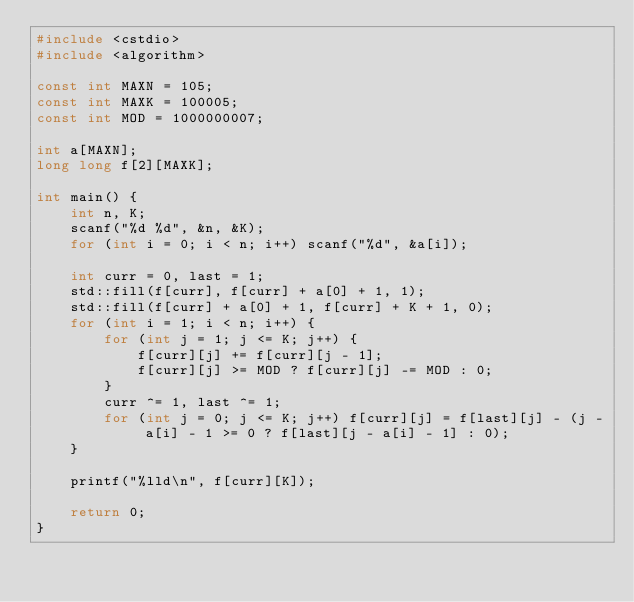<code> <loc_0><loc_0><loc_500><loc_500><_C++_>#include <cstdio>
#include <algorithm>

const int MAXN = 105;
const int MAXK = 100005;
const int MOD = 1000000007;

int a[MAXN];
long long f[2][MAXK];

int main() {
    int n, K;
    scanf("%d %d", &n, &K);
    for (int i = 0; i < n; i++) scanf("%d", &a[i]);

    int curr = 0, last = 1;
    std::fill(f[curr], f[curr] + a[0] + 1, 1);
    std::fill(f[curr] + a[0] + 1, f[curr] + K + 1, 0);
    for (int i = 1; i < n; i++) {
        for (int j = 1; j <= K; j++) {
            f[curr][j] += f[curr][j - 1];
            f[curr][j] >= MOD ? f[curr][j] -= MOD : 0;
        }
        curr ^= 1, last ^= 1;
        for (int j = 0; j <= K; j++) f[curr][j] = f[last][j] - (j - a[i] - 1 >= 0 ? f[last][j - a[i] - 1] : 0);
    }

    printf("%lld\n", f[curr][K]);
    
    return 0;
}</code> 